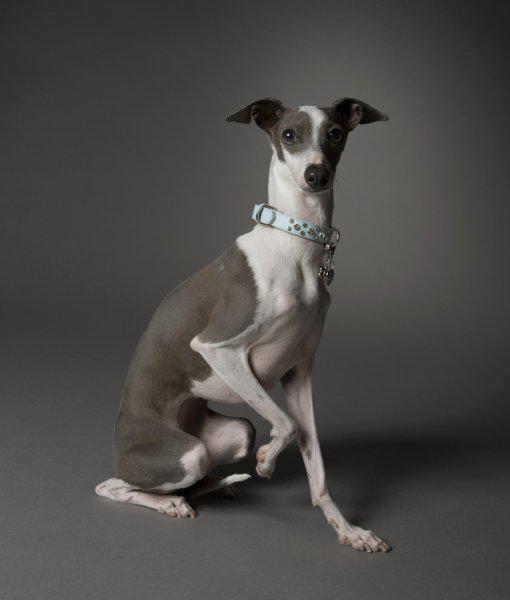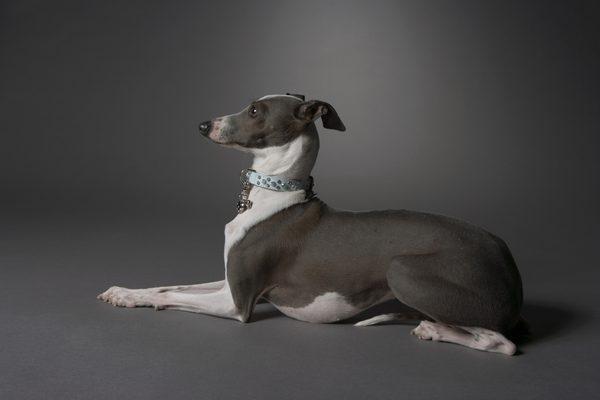The first image is the image on the left, the second image is the image on the right. Analyze the images presented: Is the assertion "All the dogs in the images are posing for portraits wearing collars." valid? Answer yes or no. Yes. 